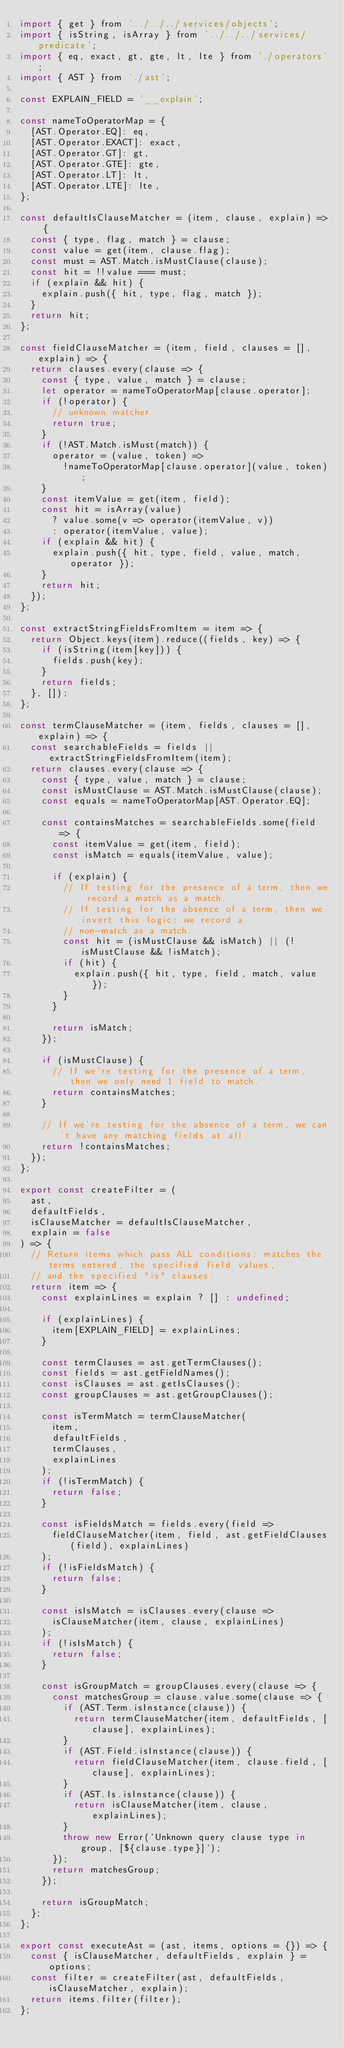<code> <loc_0><loc_0><loc_500><loc_500><_JavaScript_>import { get } from '../../../services/objects';
import { isString, isArray } from '../../../services/predicate';
import { eq, exact, gt, gte, lt, lte } from './operators';
import { AST } from './ast';

const EXPLAIN_FIELD = '__explain';

const nameToOperatorMap = {
  [AST.Operator.EQ]: eq,
  [AST.Operator.EXACT]: exact,
  [AST.Operator.GT]: gt,
  [AST.Operator.GTE]: gte,
  [AST.Operator.LT]: lt,
  [AST.Operator.LTE]: lte,
};

const defaultIsClauseMatcher = (item, clause, explain) => {
  const { type, flag, match } = clause;
  const value = get(item, clause.flag);
  const must = AST.Match.isMustClause(clause);
  const hit = !!value === must;
  if (explain && hit) {
    explain.push({ hit, type, flag, match });
  }
  return hit;
};

const fieldClauseMatcher = (item, field, clauses = [], explain) => {
  return clauses.every(clause => {
    const { type, value, match } = clause;
    let operator = nameToOperatorMap[clause.operator];
    if (!operator) {
      // unknown matcher
      return true;
    }
    if (!AST.Match.isMust(match)) {
      operator = (value, token) =>
        !nameToOperatorMap[clause.operator](value, token);
    }
    const itemValue = get(item, field);
    const hit = isArray(value)
      ? value.some(v => operator(itemValue, v))
      : operator(itemValue, value);
    if (explain && hit) {
      explain.push({ hit, type, field, value, match, operator });
    }
    return hit;
  });
};

const extractStringFieldsFromItem = item => {
  return Object.keys(item).reduce((fields, key) => {
    if (isString(item[key])) {
      fields.push(key);
    }
    return fields;
  }, []);
};

const termClauseMatcher = (item, fields, clauses = [], explain) => {
  const searchableFields = fields || extractStringFieldsFromItem(item);
  return clauses.every(clause => {
    const { type, value, match } = clause;
    const isMustClause = AST.Match.isMustClause(clause);
    const equals = nameToOperatorMap[AST.Operator.EQ];

    const containsMatches = searchableFields.some(field => {
      const itemValue = get(item, field);
      const isMatch = equals(itemValue, value);

      if (explain) {
        // If testing for the presence of a term, then we record a match as a match.
        // If testing for the absence of a term, then we invert this logic: we record a
        // non-match as a match.
        const hit = (isMustClause && isMatch) || (!isMustClause && !isMatch);
        if (hit) {
          explain.push({ hit, type, field, match, value });
        }
      }

      return isMatch;
    });

    if (isMustClause) {
      // If we're testing for the presence of a term, then we only need 1 field to match.
      return containsMatches;
    }

    // If we're testing for the absence of a term, we can't have any matching fields at all.
    return !containsMatches;
  });
};

export const createFilter = (
  ast,
  defaultFields,
  isClauseMatcher = defaultIsClauseMatcher,
  explain = false
) => {
  // Return items which pass ALL conditions: matches the terms entered, the specified field values,
  // and the specified "is" clauses.
  return item => {
    const explainLines = explain ? [] : undefined;

    if (explainLines) {
      item[EXPLAIN_FIELD] = explainLines;
    }

    const termClauses = ast.getTermClauses();
    const fields = ast.getFieldNames();
    const isClauses = ast.getIsClauses();
    const groupClauses = ast.getGroupClauses();

    const isTermMatch = termClauseMatcher(
      item,
      defaultFields,
      termClauses,
      explainLines
    );
    if (!isTermMatch) {
      return false;
    }

    const isFieldsMatch = fields.every(field =>
      fieldClauseMatcher(item, field, ast.getFieldClauses(field), explainLines)
    );
    if (!isFieldsMatch) {
      return false;
    }

    const isIsMatch = isClauses.every(clause =>
      isClauseMatcher(item, clause, explainLines)
    );
    if (!isIsMatch) {
      return false;
    }

    const isGroupMatch = groupClauses.every(clause => {
      const matchesGroup = clause.value.some(clause => {
        if (AST.Term.isInstance(clause)) {
          return termClauseMatcher(item, defaultFields, [clause], explainLines);
        }
        if (AST.Field.isInstance(clause)) {
          return fieldClauseMatcher(item, clause.field, [clause], explainLines);
        }
        if (AST.Is.isInstance(clause)) {
          return isClauseMatcher(item, clause, explainLines);
        }
        throw new Error(`Unknown query clause type in group, [${clause.type}]`);
      });
      return matchesGroup;
    });

    return isGroupMatch;
  };
};

export const executeAst = (ast, items, options = {}) => {
  const { isClauseMatcher, defaultFields, explain } = options;
  const filter = createFilter(ast, defaultFields, isClauseMatcher, explain);
  return items.filter(filter);
};
</code> 